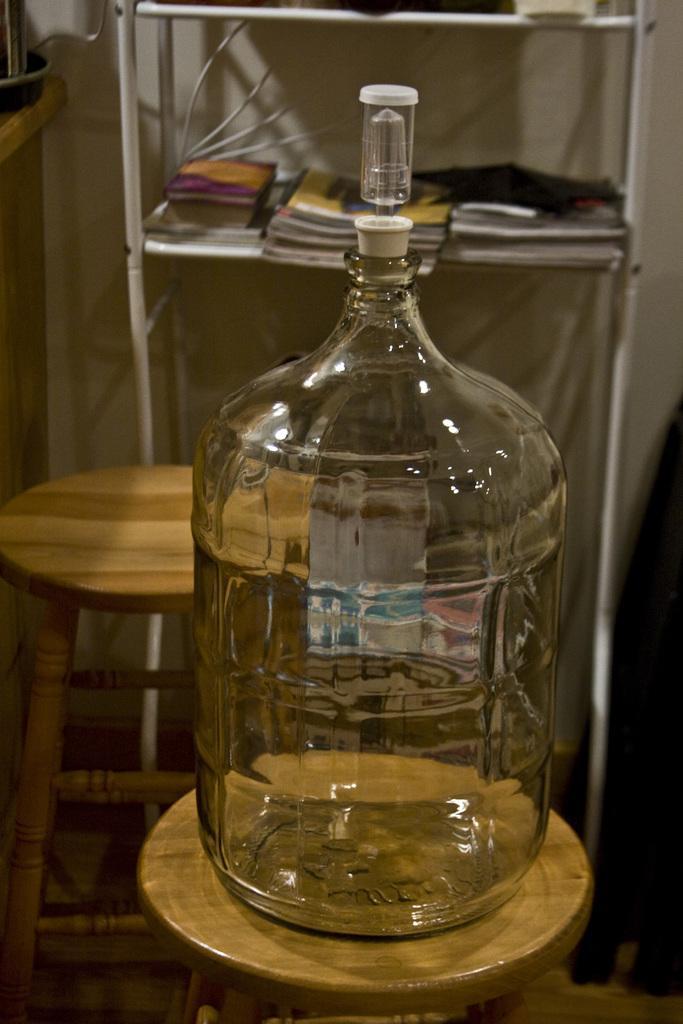In one or two sentences, can you explain what this image depicts? A glass jar is placed with a nozzle in its mouth on a stool in a room. 